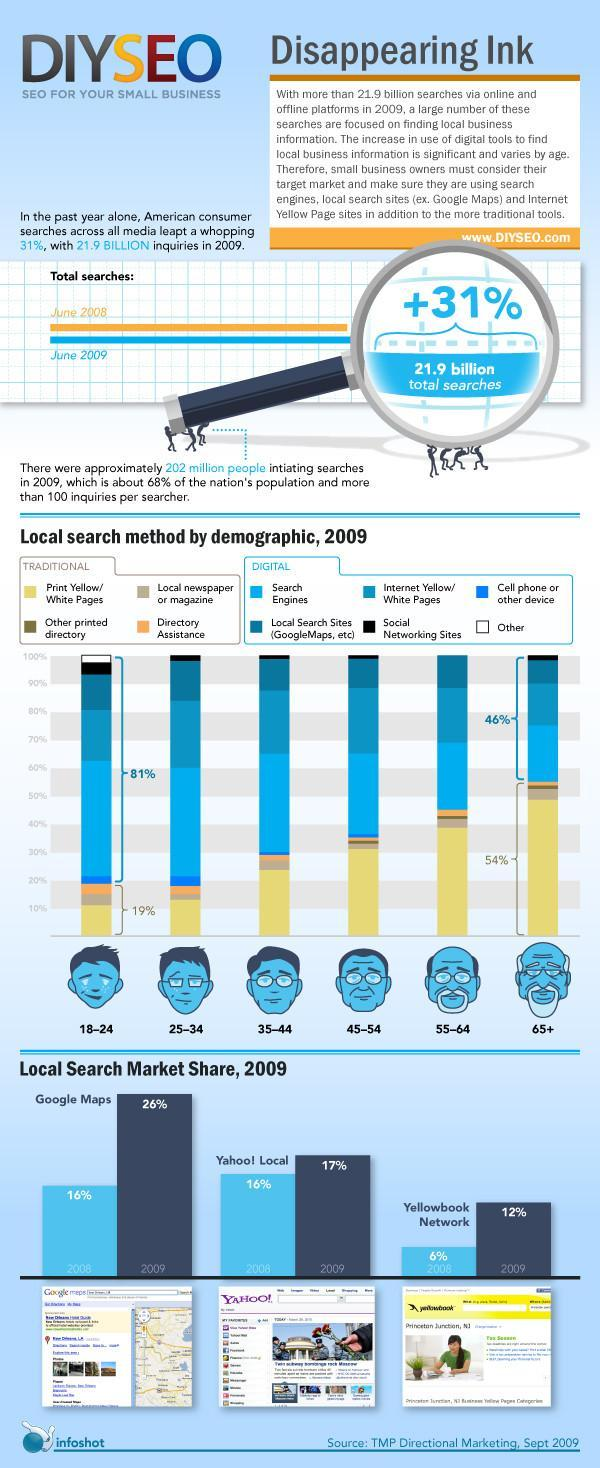In 2008, who had 16 % market share?
Answer the question with a short phrase. Google Maps What percent of market share did Yahoo! Local have in 2009? 17% What percentage of people in the age group 18-24 use traditional methods for search? 19% Which age group uses digital search methods the most? 18-24 Whose market share doubled during 2008-2009? Yellowbook Network What percentage of senior citizens use digital methods? 46% 